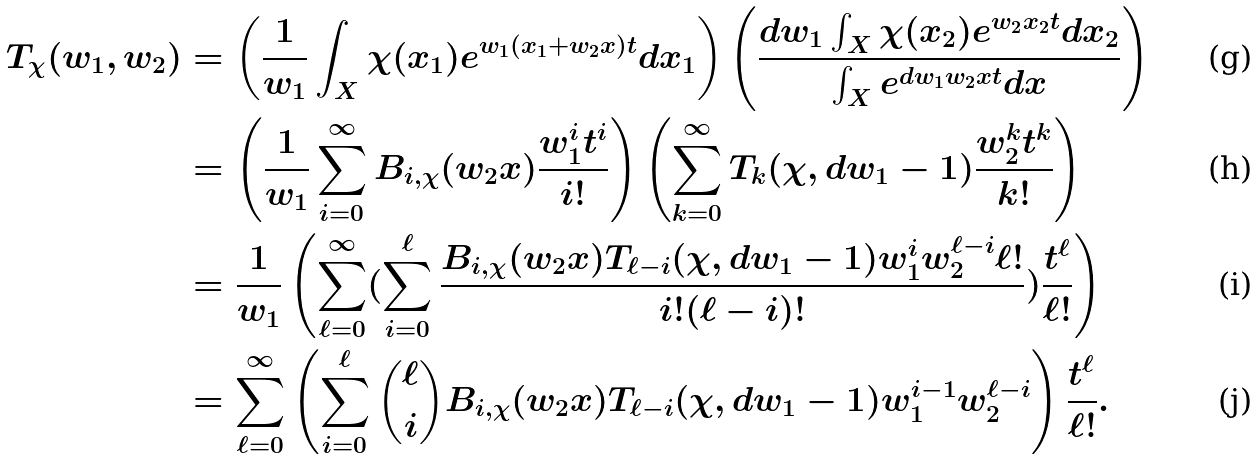<formula> <loc_0><loc_0><loc_500><loc_500>T _ { \chi } ( w _ { 1 } , w _ { 2 } ) & = \left ( \frac { 1 } { w _ { 1 } } \int _ { X } \chi ( x _ { 1 } ) e ^ { w _ { 1 } ( x _ { 1 } + w _ { 2 } x ) t } d x _ { 1 } \right ) \left ( \frac { d w _ { 1 } \int _ { X } \chi ( x _ { 2 } ) e ^ { w _ { 2 } x _ { 2 } t } d x _ { 2 } } { \int _ { X } e ^ { d w _ { 1 } w _ { 2 } x t } d x } \right ) \\ & = \left ( \frac { 1 } { w _ { 1 } } \sum _ { i = 0 } ^ { \infty } B _ { i , \chi } ( w _ { 2 } x ) \frac { w _ { 1 } ^ { i } t ^ { i } } { i ! } \right ) \left ( \sum _ { k = 0 } ^ { \infty } T _ { k } ( \chi , d w _ { 1 } - 1 ) \frac { w _ { 2 } ^ { k } t ^ { k } } { k ! } \right ) \\ & = \frac { 1 } { w _ { 1 } } \left ( \sum _ { \ell = 0 } ^ { \infty } ( \sum _ { i = 0 } ^ { \ell } \frac { B _ { i , \chi } ( w _ { 2 } x ) T _ { \ell - i } ( \chi , d w _ { 1 } - 1 ) w _ { 1 } ^ { i } w _ { 2 } ^ { \ell - i } \ell ! } { i ! ( \ell - i ) ! } ) \frac { t ^ { \ell } } { \ell ! } \right ) \\ & = \sum _ { \ell = 0 } ^ { \infty } \left ( \sum _ { i = 0 } ^ { \ell } \binom { \ell } { i } B _ { i , \chi } ( w _ { 2 } x ) T _ { \ell - i } ( \chi , d w _ { 1 } - 1 ) w _ { 1 } ^ { i - 1 } w _ { 2 } ^ { \ell - i } \right ) \frac { t ^ { \ell } } { \ell ! } .</formula> 